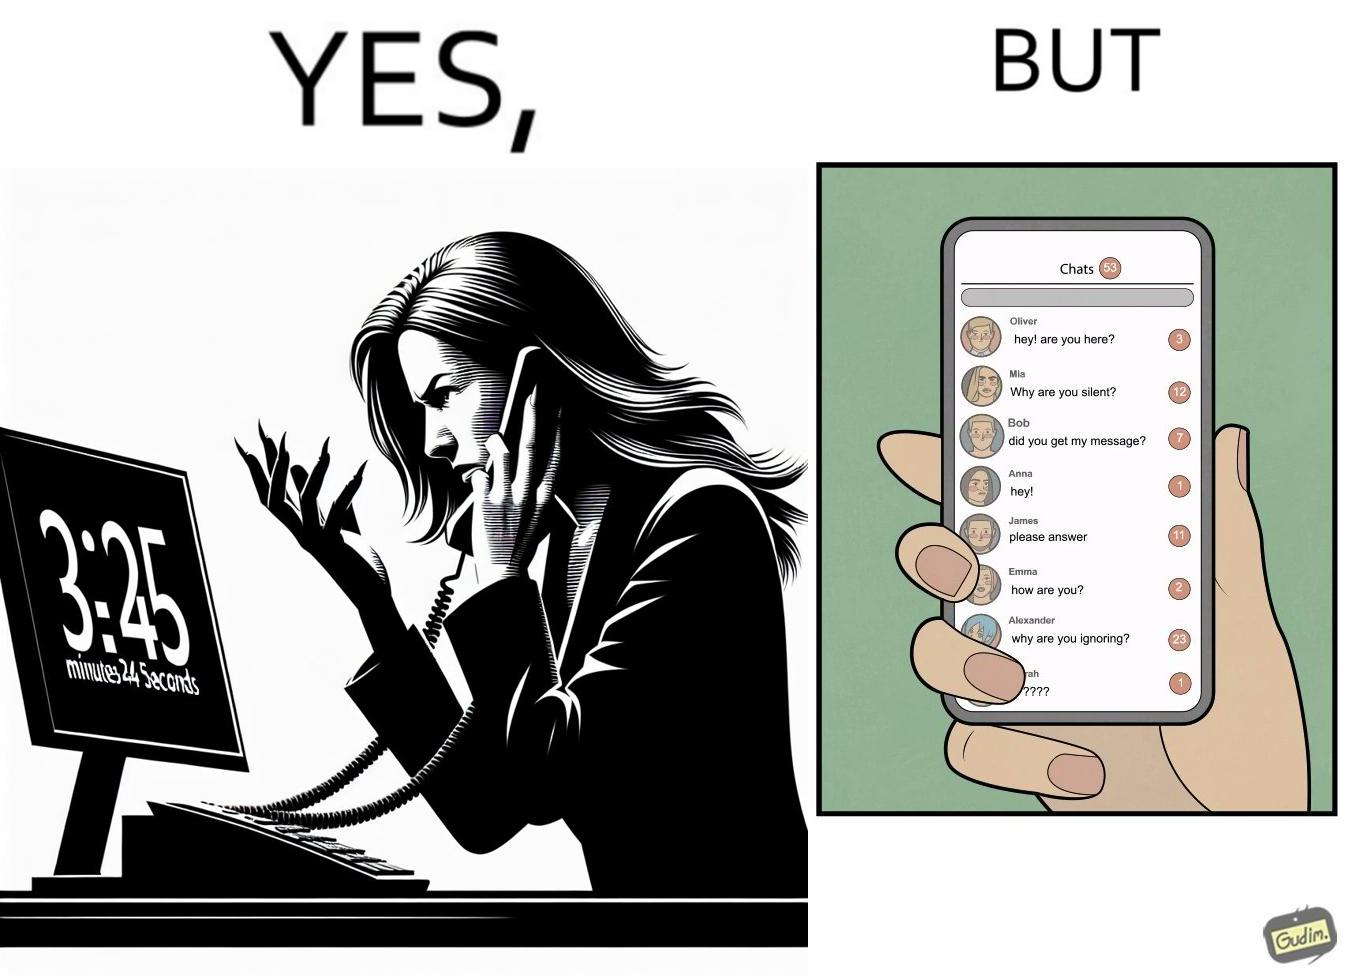Is this image satirical or non-satirical? Yes, this image is satirical. 